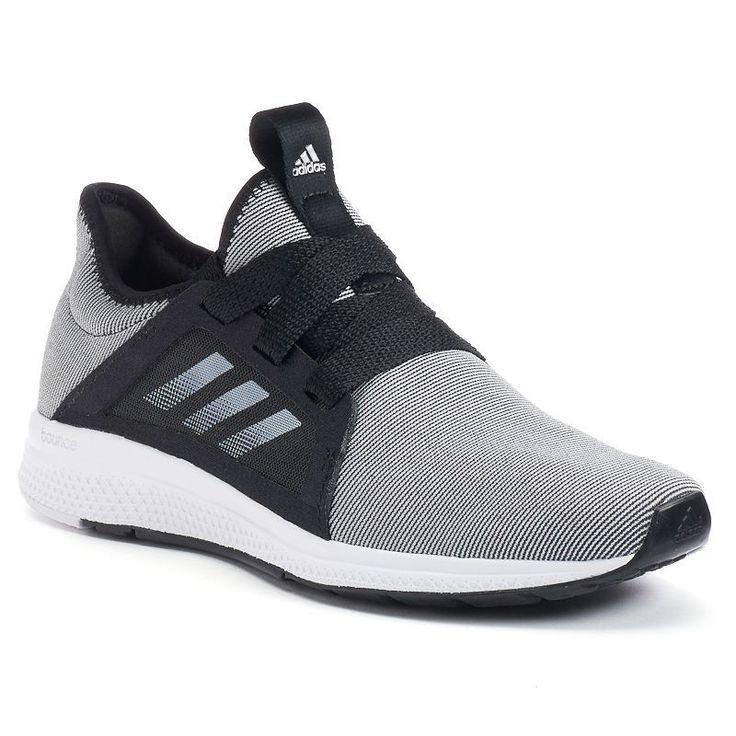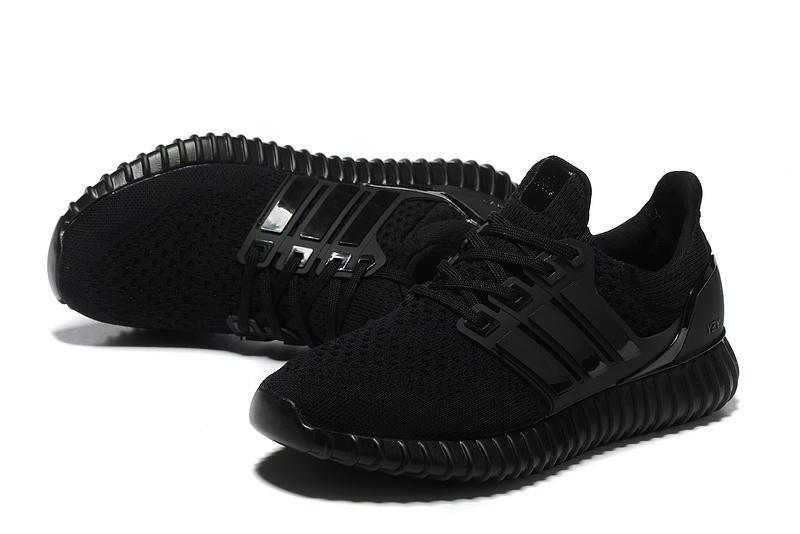The first image is the image on the left, the second image is the image on the right. Given the left and right images, does the statement "There is a part of a human visible on at least one of the images." hold true? Answer yes or no. No. 